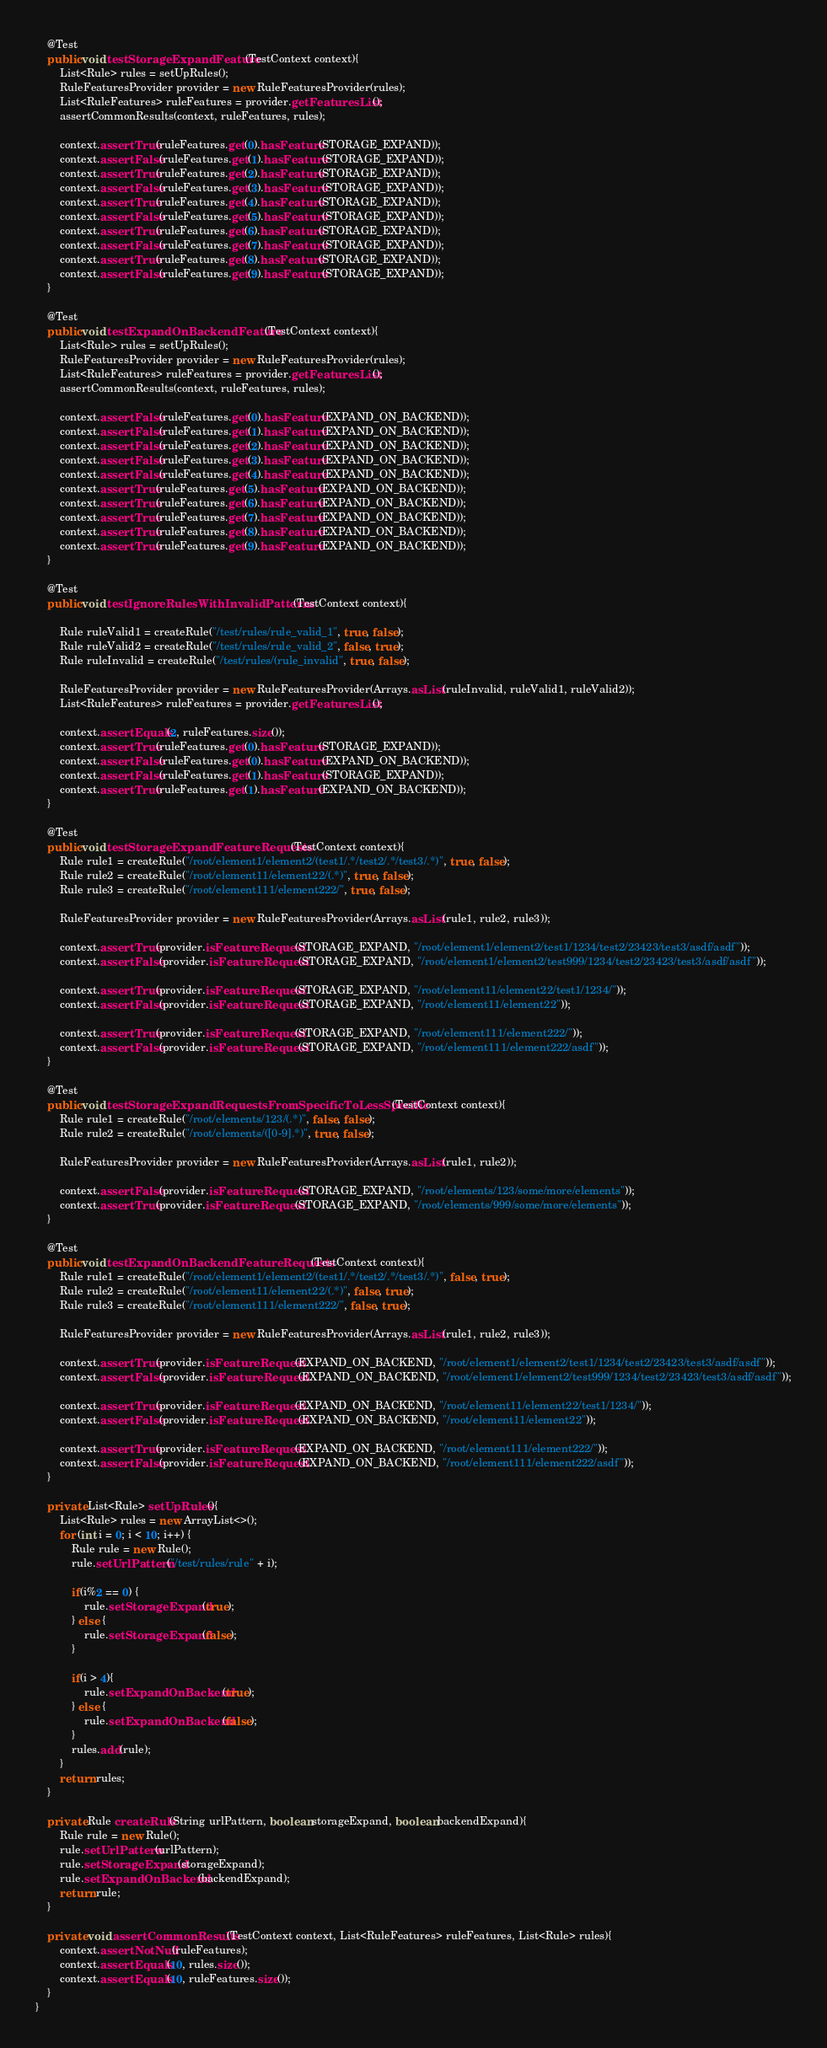Convert code to text. <code><loc_0><loc_0><loc_500><loc_500><_Java_>    @Test
    public void testStorageExpandFeature(TestContext context){
        List<Rule> rules = setUpRules();
        RuleFeaturesProvider provider = new RuleFeaturesProvider(rules);
        List<RuleFeatures> ruleFeatures = provider.getFeaturesList();
        assertCommonResults(context, ruleFeatures, rules);

        context.assertTrue(ruleFeatures.get(0).hasFeature(STORAGE_EXPAND));
        context.assertFalse(ruleFeatures.get(1).hasFeature(STORAGE_EXPAND));
        context.assertTrue(ruleFeatures.get(2).hasFeature(STORAGE_EXPAND));
        context.assertFalse(ruleFeatures.get(3).hasFeature(STORAGE_EXPAND));
        context.assertTrue(ruleFeatures.get(4).hasFeature(STORAGE_EXPAND));
        context.assertFalse(ruleFeatures.get(5).hasFeature(STORAGE_EXPAND));
        context.assertTrue(ruleFeatures.get(6).hasFeature(STORAGE_EXPAND));
        context.assertFalse(ruleFeatures.get(7).hasFeature(STORAGE_EXPAND));
        context.assertTrue(ruleFeatures.get(8).hasFeature(STORAGE_EXPAND));
        context.assertFalse(ruleFeatures.get(9).hasFeature(STORAGE_EXPAND));
    }

    @Test
    public void testExpandOnBackendFeature(TestContext context){
        List<Rule> rules = setUpRules();
        RuleFeaturesProvider provider = new RuleFeaturesProvider(rules);
        List<RuleFeatures> ruleFeatures = provider.getFeaturesList();
        assertCommonResults(context, ruleFeatures, rules);

        context.assertFalse(ruleFeatures.get(0).hasFeature(EXPAND_ON_BACKEND));
        context.assertFalse(ruleFeatures.get(1).hasFeature(EXPAND_ON_BACKEND));
        context.assertFalse(ruleFeatures.get(2).hasFeature(EXPAND_ON_BACKEND));
        context.assertFalse(ruleFeatures.get(3).hasFeature(EXPAND_ON_BACKEND));
        context.assertFalse(ruleFeatures.get(4).hasFeature(EXPAND_ON_BACKEND));
        context.assertTrue(ruleFeatures.get(5).hasFeature(EXPAND_ON_BACKEND));
        context.assertTrue(ruleFeatures.get(6).hasFeature(EXPAND_ON_BACKEND));
        context.assertTrue(ruleFeatures.get(7).hasFeature(EXPAND_ON_BACKEND));
        context.assertTrue(ruleFeatures.get(8).hasFeature(EXPAND_ON_BACKEND));
        context.assertTrue(ruleFeatures.get(9).hasFeature(EXPAND_ON_BACKEND));
    }

    @Test
    public void testIgnoreRulesWithInvalidPatterns(TestContext context){

        Rule ruleValid1 = createRule("/test/rules/rule_valid_1", true, false);
        Rule ruleValid2 = createRule("/test/rules/rule_valid_2", false, true);
        Rule ruleInvalid = createRule("/test/rules/(rule_invalid", true, false);

        RuleFeaturesProvider provider = new RuleFeaturesProvider(Arrays.asList(ruleInvalid, ruleValid1, ruleValid2));
        List<RuleFeatures> ruleFeatures = provider.getFeaturesList();

        context.assertEquals(2, ruleFeatures.size());
        context.assertTrue(ruleFeatures.get(0).hasFeature(STORAGE_EXPAND));
        context.assertFalse(ruleFeatures.get(0).hasFeature(EXPAND_ON_BACKEND));
        context.assertFalse(ruleFeatures.get(1).hasFeature(STORAGE_EXPAND));
        context.assertTrue(ruleFeatures.get(1).hasFeature(EXPAND_ON_BACKEND));
    }

    @Test
    public void testStorageExpandFeatureRequests(TestContext context){
        Rule rule1 = createRule("/root/element1/element2/(test1/.*/test2/.*/test3/.*)", true, false);
        Rule rule2 = createRule("/root/element11/element22/(.*)", true, false);
        Rule rule3 = createRule("/root/element111/element222/", true, false);

        RuleFeaturesProvider provider = new RuleFeaturesProvider(Arrays.asList(rule1, rule2, rule3));

        context.assertTrue(provider.isFeatureRequest(STORAGE_EXPAND, "/root/element1/element2/test1/1234/test2/23423/test3/asdf/asdf"));
        context.assertFalse(provider.isFeatureRequest(STORAGE_EXPAND, "/root/element1/element2/test999/1234/test2/23423/test3/asdf/asdf"));

        context.assertTrue(provider.isFeatureRequest(STORAGE_EXPAND, "/root/element11/element22/test1/1234/"));
        context.assertFalse(provider.isFeatureRequest(STORAGE_EXPAND, "/root/element11/element22"));

        context.assertTrue(provider.isFeatureRequest(STORAGE_EXPAND, "/root/element111/element222/"));
        context.assertFalse(provider.isFeatureRequest(STORAGE_EXPAND, "/root/element111/element222/asdf"));
    }

    @Test
    public void testStorageExpandRequestsFromSpecificToLessSpecific(TestContext context){
        Rule rule1 = createRule("/root/elements/123/(.*)", false, false);
        Rule rule2 = createRule("/root/elements/([0-9].*)", true, false);

        RuleFeaturesProvider provider = new RuleFeaturesProvider(Arrays.asList(rule1, rule2));

        context.assertFalse(provider.isFeatureRequest(STORAGE_EXPAND, "/root/elements/123/some/more/elements"));
        context.assertTrue(provider.isFeatureRequest(STORAGE_EXPAND, "/root/elements/999/some/more/elements"));
    }

    @Test
    public void testExpandOnBackendFeatureRequests(TestContext context){
        Rule rule1 = createRule("/root/element1/element2/(test1/.*/test2/.*/test3/.*)", false, true);
        Rule rule2 = createRule("/root/element11/element22/(.*)", false, true);
        Rule rule3 = createRule("/root/element111/element222/", false, true);

        RuleFeaturesProvider provider = new RuleFeaturesProvider(Arrays.asList(rule1, rule2, rule3));

        context.assertTrue(provider.isFeatureRequest(EXPAND_ON_BACKEND, "/root/element1/element2/test1/1234/test2/23423/test3/asdf/asdf"));
        context.assertFalse(provider.isFeatureRequest(EXPAND_ON_BACKEND, "/root/element1/element2/test999/1234/test2/23423/test3/asdf/asdf"));

        context.assertTrue(provider.isFeatureRequest(EXPAND_ON_BACKEND, "/root/element11/element22/test1/1234/"));
        context.assertFalse(provider.isFeatureRequest(EXPAND_ON_BACKEND, "/root/element11/element22"));

        context.assertTrue(provider.isFeatureRequest(EXPAND_ON_BACKEND, "/root/element111/element222/"));
        context.assertFalse(provider.isFeatureRequest(EXPAND_ON_BACKEND, "/root/element111/element222/asdf"));
    }

    private List<Rule> setUpRules(){
        List<Rule> rules = new ArrayList<>();
        for (int i = 0; i < 10; i++) {
            Rule rule = new Rule();
            rule.setUrlPattern("/test/rules/rule" + i);

            if(i%2 == 0) {
                rule.setStorageExpand(true);
            } else {
                rule.setStorageExpand(false);
            }

            if(i > 4){
                rule.setExpandOnBackend(true);
            } else {
                rule.setExpandOnBackend(false);
            }
            rules.add(rule);
        }
        return rules;
    }

    private Rule createRule(String urlPattern, boolean storageExpand, boolean backendExpand){
        Rule rule = new Rule();
        rule.setUrlPattern(urlPattern);
        rule.setStorageExpand(storageExpand);
        rule.setExpandOnBackend(backendExpand);
        return rule;
    }

    private void assertCommonResults(TestContext context, List<RuleFeatures> ruleFeatures, List<Rule> rules){
        context.assertNotNull(ruleFeatures);
        context.assertEquals(10, rules.size());
        context.assertEquals(10, ruleFeatures.size());
    }
}
</code> 